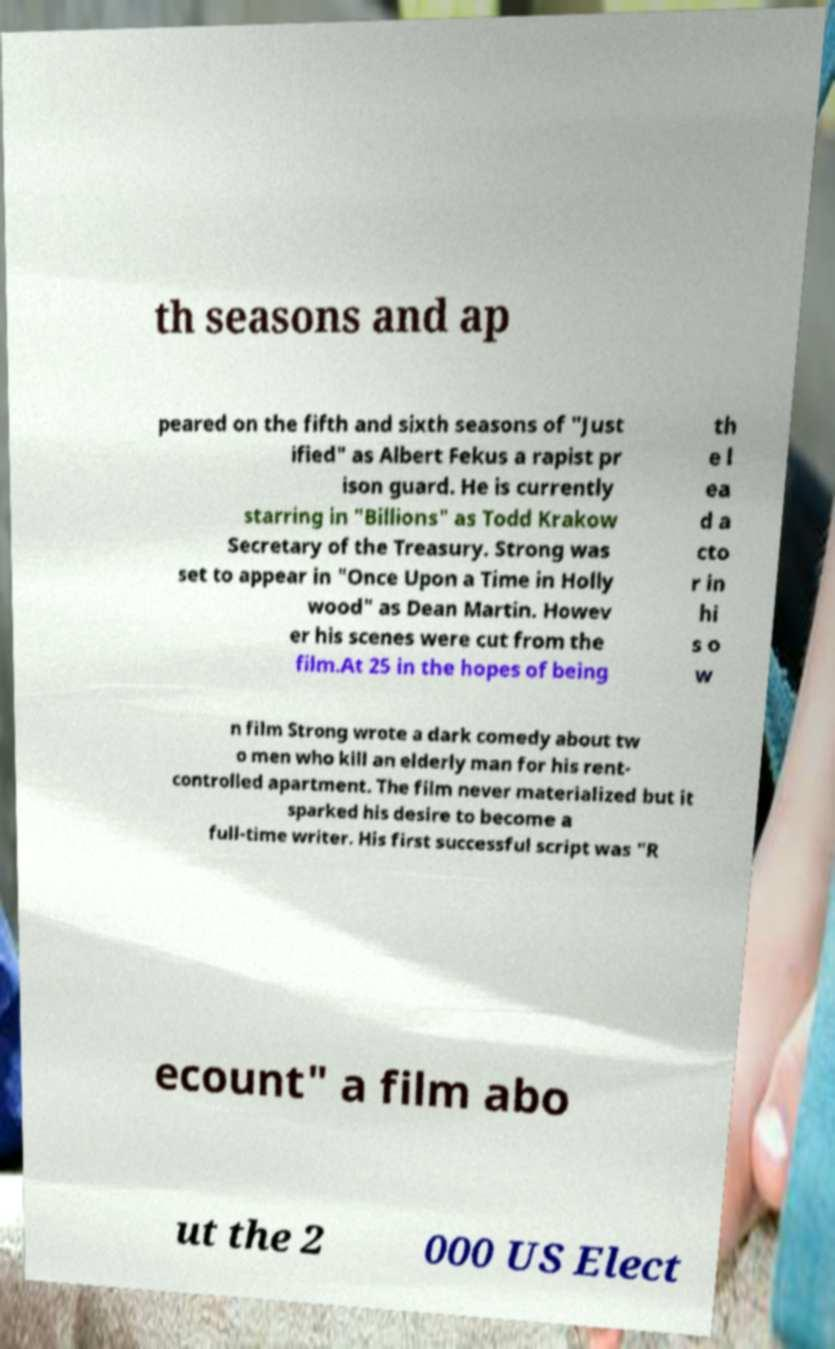There's text embedded in this image that I need extracted. Can you transcribe it verbatim? th seasons and ap peared on the fifth and sixth seasons of "Just ified" as Albert Fekus a rapist pr ison guard. He is currently starring in "Billions" as Todd Krakow Secretary of the Treasury. Strong was set to appear in "Once Upon a Time in Holly wood" as Dean Martin. Howev er his scenes were cut from the film.At 25 in the hopes of being th e l ea d a cto r in hi s o w n film Strong wrote a dark comedy about tw o men who kill an elderly man for his rent- controlled apartment. The film never materialized but it sparked his desire to become a full-time writer. His first successful script was "R ecount" a film abo ut the 2 000 US Elect 